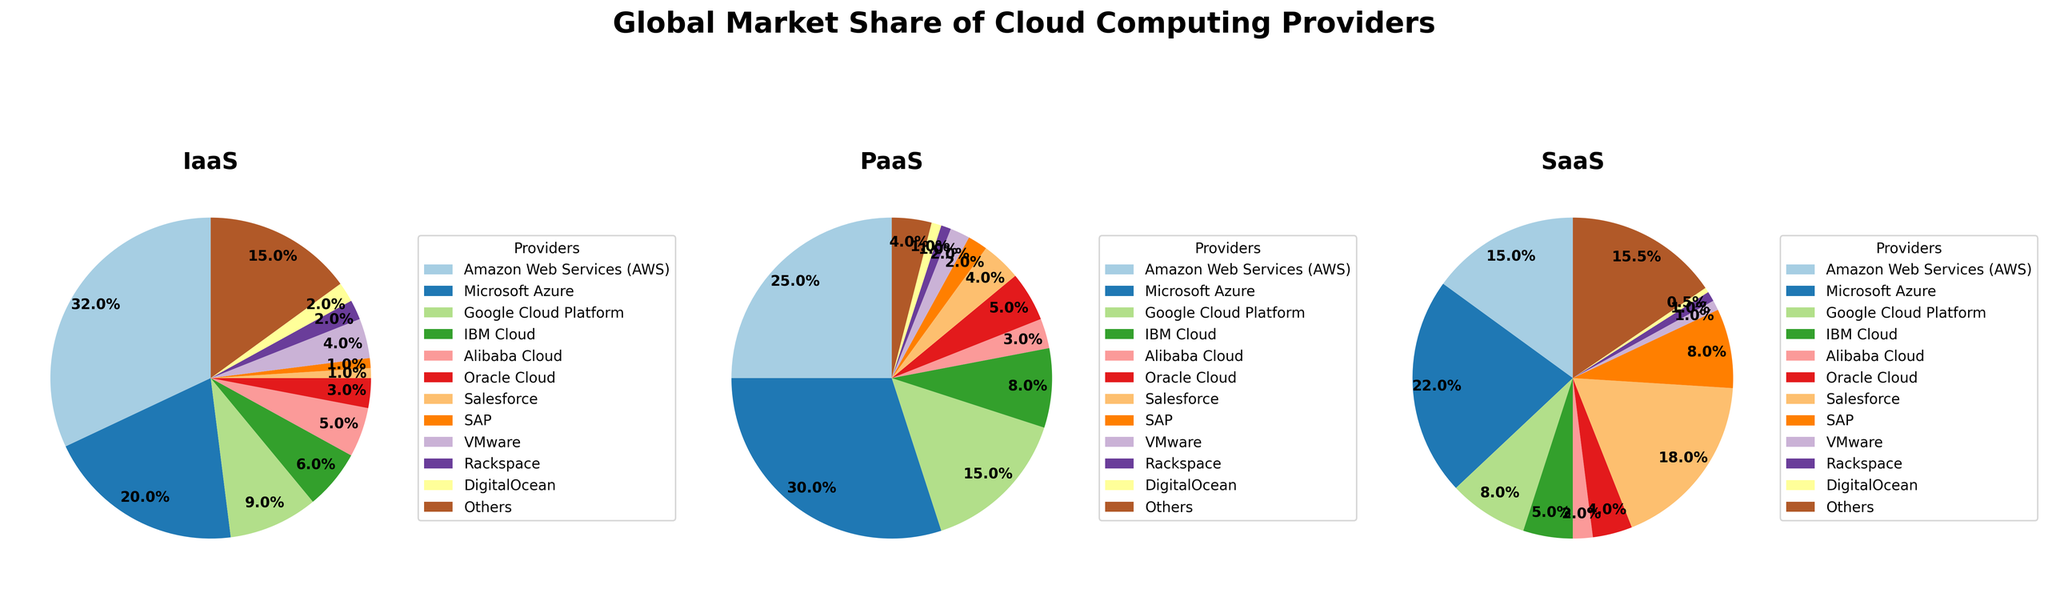Which provider has the largest market share in IaaS? In the IaaS pie chart, Amazon Web Services (AWS) has the largest slice.
Answer: Amazon Web Services (AWS) Which service type does Microsoft Azure dominate in market share? In the PaaS pie chart, Microsoft Azure has the largest slice, indicating it dominates the PaaS market share.
Answer: PaaS Compare the market shares of AWS and Google Cloud Platform in the IaaS category. In the IaaS pie chart, AWS has a much larger slice compared to Google Cloud Platform, implying a larger market share for AWS in IaaS.
Answer: AWS has a larger market share What is the combined market share of SaaS for SAP and Salesforce? Looking at the SaaS pie chart, Salesforce has 18% and SAP has 8%. Adding them gives 18% + 8% = 26%.
Answer: 26% Which providers have a market share of 5% or less in the PaaS category? In the PaaS pie chart, Alibaba Cloud (3%), Oracle Cloud (5%), SAP (2%), VMware (2%), Rackspace (1%), and DigitalOcean (1%) all have 5% or less.
Answer: Alibaba Cloud, Oracle Cloud, SAP, VMware, Rackspace, DigitalOcean Is the market share of Microsoft Azure in the IaaS category greater than that of Google Cloud Platform in the SaaS category? Microsoft Azure has a market share of 20% in IaaS, while Google Cloud Platform has a market share of 8% in the SaaS. Therefore, Microsoft Azure's share is greater.
Answer: Yes What is the difference between AWS's and Microsoft's market share in the SaaS category? In the SaaS pie chart, AWS has 15% and Microsoft has 22%. The difference is 22% - 15% = 7%.
Answer: 7% Rank the providers by their IaaS market share in descending order. From the IaaS pie chart, the order is AWS (32%), Microsoft Azure (20%), Google Cloud Platform (9%), IBM Cloud (6%), VMware (4%), Others (15%).
Answer: AWS, Microsoft Azure, Others, Google Cloud Platform, IBM Cloud, VMware What percentage of the PaaS market is held by providers outside of AWS, Microsoft Azure, and Google Cloud Platform? In the PaaS pie chart, Others have 4%, IBM Cloud 8%, Alibaba Cloud 3%, Oracle Cloud 5%, Salesforce 4%, SAP 2%, VMware 2%, Rackspace 1%, DigitalOcean 1%. Summing these gives 4 + 8 + 3 + 5 + 4 + 2 + 2 + 1 + 1 = 30%.
Answer: 30% 